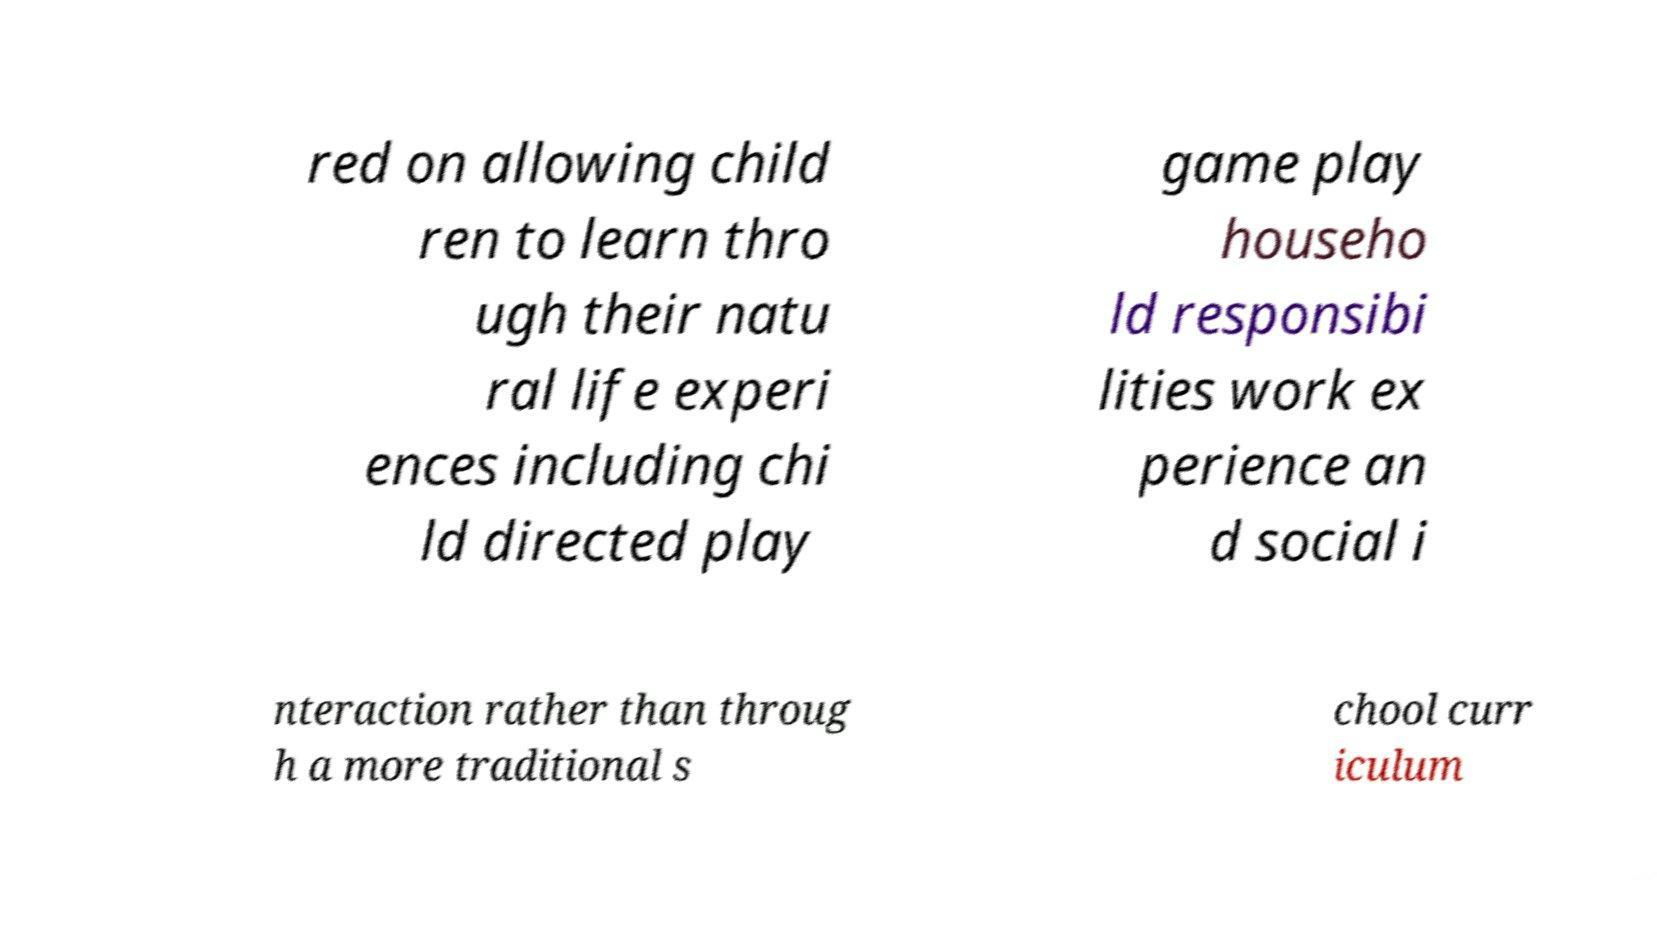Can you accurately transcribe the text from the provided image for me? red on allowing child ren to learn thro ugh their natu ral life experi ences including chi ld directed play game play househo ld responsibi lities work ex perience an d social i nteraction rather than throug h a more traditional s chool curr iculum 